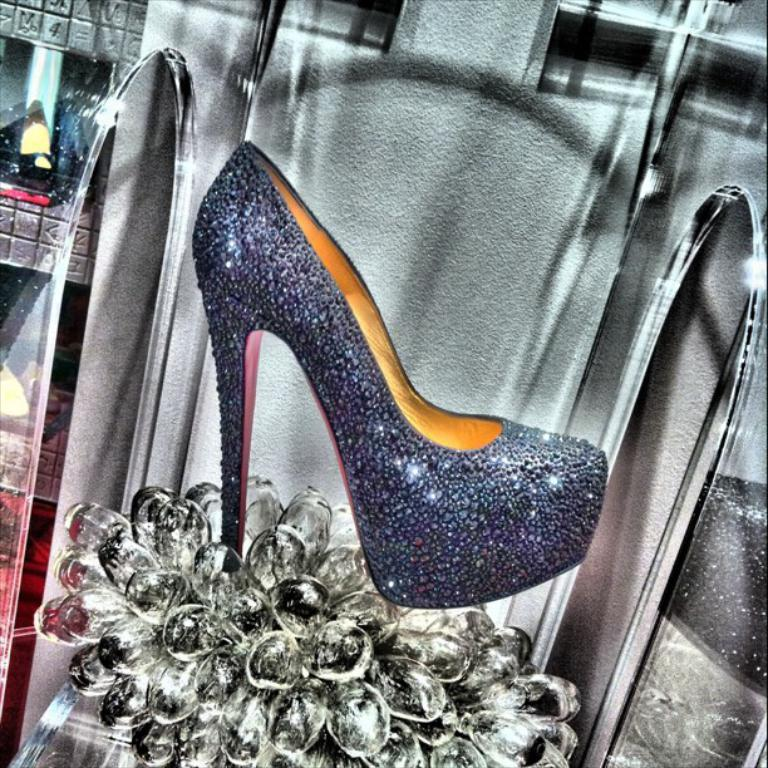What type of footwear is visible in the image? There is footwear in the image, but the specific type cannot be determined from the facts provided. Where is the footwear placed in the image? The footwear is on an object in the image. What is the object on which the footwear is placed resting on? The object is on a platform in the image. What other items can be seen in the image besides the footwear and the object? There are mirrors and other objects in the image. What type of teeth can be seen in the image? There are no teeth visible in the image. 